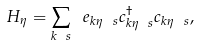Convert formula to latex. <formula><loc_0><loc_0><loc_500><loc_500>H _ { \eta } = \sum _ { k \ s } \ e _ { k \eta \ s } c _ { k \eta \ s } ^ { \dagger } c _ { k \eta \ s } ,</formula> 